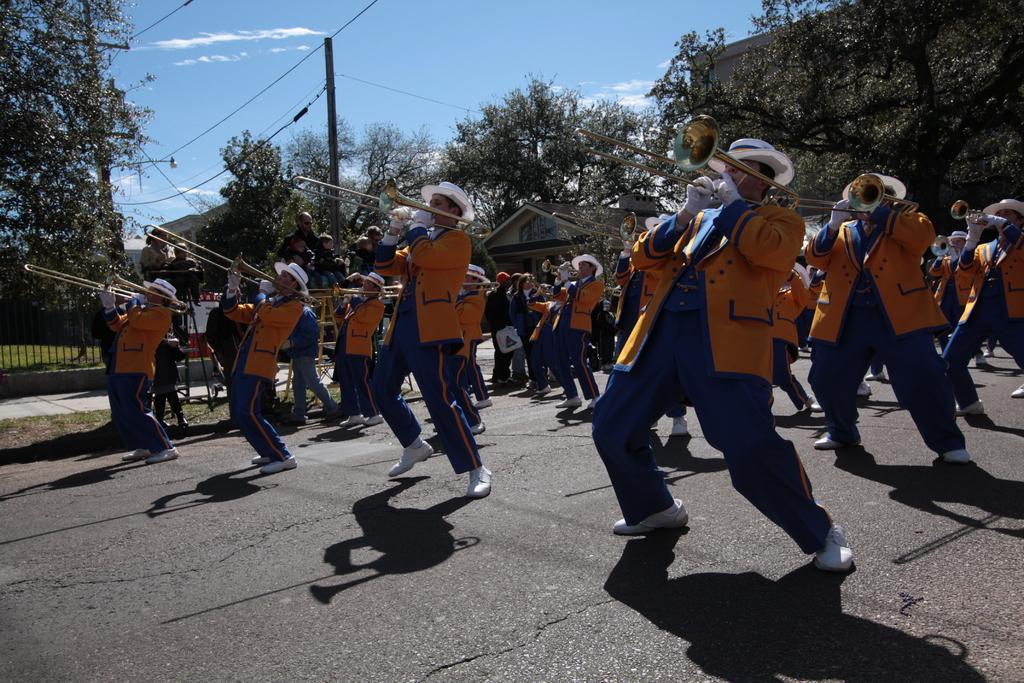Please provide a concise description of this image. In this image we can see many people on the road. They are wearing hats and playing musical instruments. In the back there are trees. Also there is an electric pole with wires. On the left side there is a railing. In the back there are buildings and sky with clouds. 